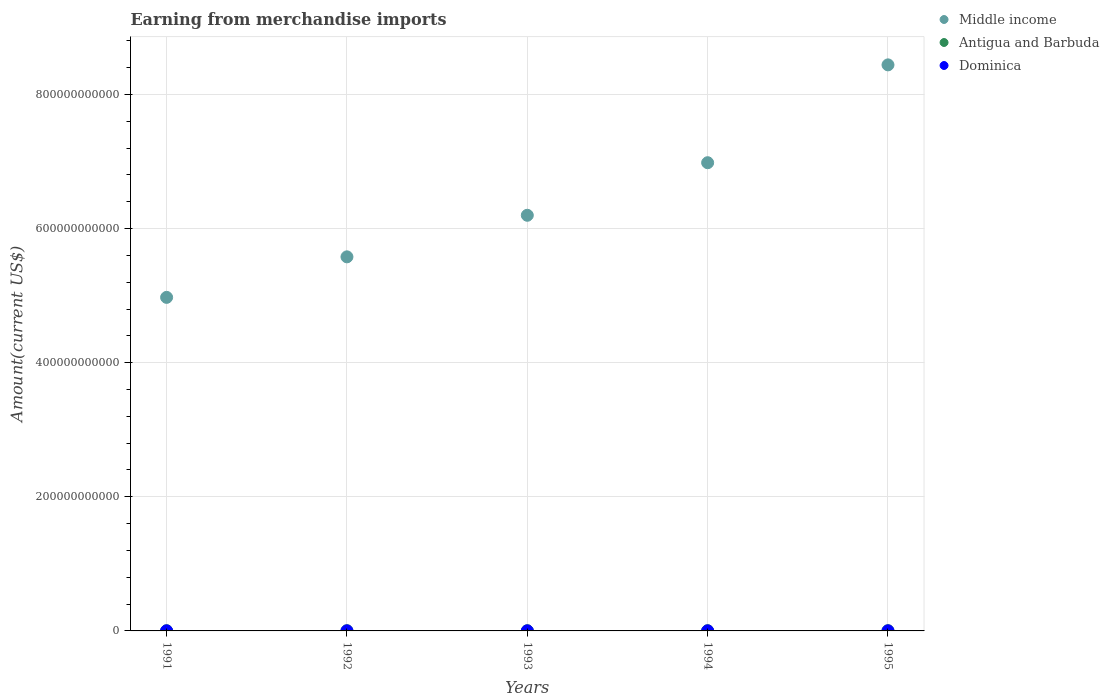How many different coloured dotlines are there?
Your answer should be compact. 3. What is the amount earned from merchandise imports in Middle income in 1995?
Offer a terse response. 8.44e+11. Across all years, what is the maximum amount earned from merchandise imports in Dominica?
Give a very brief answer. 1.17e+08. Across all years, what is the minimum amount earned from merchandise imports in Middle income?
Ensure brevity in your answer.  4.97e+11. What is the total amount earned from merchandise imports in Antigua and Barbuda in the graph?
Your answer should be compact. 1.62e+09. What is the difference between the amount earned from merchandise imports in Middle income in 1991 and that in 1994?
Offer a terse response. -2.01e+11. What is the difference between the amount earned from merchandise imports in Dominica in 1993 and the amount earned from merchandise imports in Middle income in 1991?
Provide a short and direct response. -4.97e+11. What is the average amount earned from merchandise imports in Antigua and Barbuda per year?
Ensure brevity in your answer.  3.24e+08. In the year 1993, what is the difference between the amount earned from merchandise imports in Dominica and amount earned from merchandise imports in Middle income?
Make the answer very short. -6.20e+11. In how many years, is the amount earned from merchandise imports in Antigua and Barbuda greater than 40000000000 US$?
Provide a succinct answer. 0. What is the ratio of the amount earned from merchandise imports in Dominica in 1991 to that in 1994?
Your response must be concise. 1.15. Is the amount earned from merchandise imports in Antigua and Barbuda in 1993 less than that in 1994?
Your response must be concise. Yes. Is the difference between the amount earned from merchandise imports in Dominica in 1991 and 1994 greater than the difference between the amount earned from merchandise imports in Middle income in 1991 and 1994?
Your answer should be compact. Yes. What is the difference between the highest and the second highest amount earned from merchandise imports in Antigua and Barbuda?
Give a very brief answer. 4.00e+06. What is the difference between the highest and the lowest amount earned from merchandise imports in Dominica?
Ensure brevity in your answer.  2.30e+07. In how many years, is the amount earned from merchandise imports in Antigua and Barbuda greater than the average amount earned from merchandise imports in Antigua and Barbuda taken over all years?
Give a very brief answer. 2. Is it the case that in every year, the sum of the amount earned from merchandise imports in Middle income and amount earned from merchandise imports in Dominica  is greater than the amount earned from merchandise imports in Antigua and Barbuda?
Offer a terse response. Yes. Does the amount earned from merchandise imports in Antigua and Barbuda monotonically increase over the years?
Your answer should be compact. Yes. Is the amount earned from merchandise imports in Antigua and Barbuda strictly less than the amount earned from merchandise imports in Dominica over the years?
Keep it short and to the point. No. What is the difference between two consecutive major ticks on the Y-axis?
Offer a very short reply. 2.00e+11. Does the graph contain any zero values?
Your answer should be compact. No. Does the graph contain grids?
Offer a terse response. Yes. How many legend labels are there?
Provide a succinct answer. 3. How are the legend labels stacked?
Provide a succinct answer. Vertical. What is the title of the graph?
Provide a short and direct response. Earning from merchandise imports. What is the label or title of the X-axis?
Provide a succinct answer. Years. What is the label or title of the Y-axis?
Your answer should be very brief. Amount(current US$). What is the Amount(current US$) of Middle income in 1991?
Ensure brevity in your answer.  4.97e+11. What is the Amount(current US$) of Antigua and Barbuda in 1991?
Keep it short and to the point. 2.95e+08. What is the Amount(current US$) of Dominica in 1991?
Give a very brief answer. 1.10e+08. What is the Amount(current US$) of Middle income in 1992?
Offer a very short reply. 5.58e+11. What is the Amount(current US$) of Antigua and Barbuda in 1992?
Offer a very short reply. 3.12e+08. What is the Amount(current US$) in Dominica in 1992?
Provide a short and direct response. 1.05e+08. What is the Amount(current US$) in Middle income in 1993?
Make the answer very short. 6.20e+11. What is the Amount(current US$) in Antigua and Barbuda in 1993?
Provide a short and direct response. 3.23e+08. What is the Amount(current US$) of Dominica in 1993?
Make the answer very short. 9.40e+07. What is the Amount(current US$) in Middle income in 1994?
Provide a short and direct response. 6.98e+11. What is the Amount(current US$) in Antigua and Barbuda in 1994?
Your answer should be very brief. 3.42e+08. What is the Amount(current US$) of Dominica in 1994?
Ensure brevity in your answer.  9.60e+07. What is the Amount(current US$) of Middle income in 1995?
Provide a succinct answer. 8.44e+11. What is the Amount(current US$) in Antigua and Barbuda in 1995?
Offer a very short reply. 3.46e+08. What is the Amount(current US$) of Dominica in 1995?
Offer a terse response. 1.17e+08. Across all years, what is the maximum Amount(current US$) in Middle income?
Provide a succinct answer. 8.44e+11. Across all years, what is the maximum Amount(current US$) of Antigua and Barbuda?
Provide a succinct answer. 3.46e+08. Across all years, what is the maximum Amount(current US$) of Dominica?
Keep it short and to the point. 1.17e+08. Across all years, what is the minimum Amount(current US$) of Middle income?
Provide a short and direct response. 4.97e+11. Across all years, what is the minimum Amount(current US$) in Antigua and Barbuda?
Provide a succinct answer. 2.95e+08. Across all years, what is the minimum Amount(current US$) of Dominica?
Give a very brief answer. 9.40e+07. What is the total Amount(current US$) in Middle income in the graph?
Make the answer very short. 3.22e+12. What is the total Amount(current US$) of Antigua and Barbuda in the graph?
Keep it short and to the point. 1.62e+09. What is the total Amount(current US$) in Dominica in the graph?
Ensure brevity in your answer.  5.22e+08. What is the difference between the Amount(current US$) of Middle income in 1991 and that in 1992?
Your answer should be very brief. -6.04e+1. What is the difference between the Amount(current US$) in Antigua and Barbuda in 1991 and that in 1992?
Your answer should be compact. -1.70e+07. What is the difference between the Amount(current US$) of Middle income in 1991 and that in 1993?
Keep it short and to the point. -1.22e+11. What is the difference between the Amount(current US$) in Antigua and Barbuda in 1991 and that in 1993?
Keep it short and to the point. -2.80e+07. What is the difference between the Amount(current US$) in Dominica in 1991 and that in 1993?
Provide a succinct answer. 1.60e+07. What is the difference between the Amount(current US$) in Middle income in 1991 and that in 1994?
Provide a succinct answer. -2.01e+11. What is the difference between the Amount(current US$) in Antigua and Barbuda in 1991 and that in 1994?
Give a very brief answer. -4.70e+07. What is the difference between the Amount(current US$) in Dominica in 1991 and that in 1994?
Offer a terse response. 1.40e+07. What is the difference between the Amount(current US$) in Middle income in 1991 and that in 1995?
Your answer should be compact. -3.47e+11. What is the difference between the Amount(current US$) in Antigua and Barbuda in 1991 and that in 1995?
Offer a terse response. -5.10e+07. What is the difference between the Amount(current US$) in Dominica in 1991 and that in 1995?
Offer a terse response. -7.00e+06. What is the difference between the Amount(current US$) of Middle income in 1992 and that in 1993?
Ensure brevity in your answer.  -6.20e+1. What is the difference between the Amount(current US$) in Antigua and Barbuda in 1992 and that in 1993?
Offer a very short reply. -1.10e+07. What is the difference between the Amount(current US$) in Dominica in 1992 and that in 1993?
Ensure brevity in your answer.  1.10e+07. What is the difference between the Amount(current US$) in Middle income in 1992 and that in 1994?
Make the answer very short. -1.40e+11. What is the difference between the Amount(current US$) of Antigua and Barbuda in 1992 and that in 1994?
Your response must be concise. -3.00e+07. What is the difference between the Amount(current US$) of Dominica in 1992 and that in 1994?
Make the answer very short. 9.00e+06. What is the difference between the Amount(current US$) in Middle income in 1992 and that in 1995?
Provide a short and direct response. -2.86e+11. What is the difference between the Amount(current US$) in Antigua and Barbuda in 1992 and that in 1995?
Provide a short and direct response. -3.40e+07. What is the difference between the Amount(current US$) in Dominica in 1992 and that in 1995?
Provide a succinct answer. -1.20e+07. What is the difference between the Amount(current US$) of Middle income in 1993 and that in 1994?
Keep it short and to the point. -7.84e+1. What is the difference between the Amount(current US$) of Antigua and Barbuda in 1993 and that in 1994?
Your answer should be very brief. -1.90e+07. What is the difference between the Amount(current US$) of Dominica in 1993 and that in 1994?
Give a very brief answer. -2.00e+06. What is the difference between the Amount(current US$) of Middle income in 1993 and that in 1995?
Provide a short and direct response. -2.24e+11. What is the difference between the Amount(current US$) of Antigua and Barbuda in 1993 and that in 1995?
Give a very brief answer. -2.30e+07. What is the difference between the Amount(current US$) of Dominica in 1993 and that in 1995?
Provide a succinct answer. -2.30e+07. What is the difference between the Amount(current US$) in Middle income in 1994 and that in 1995?
Your answer should be compact. -1.46e+11. What is the difference between the Amount(current US$) in Dominica in 1994 and that in 1995?
Your response must be concise. -2.10e+07. What is the difference between the Amount(current US$) of Middle income in 1991 and the Amount(current US$) of Antigua and Barbuda in 1992?
Give a very brief answer. 4.97e+11. What is the difference between the Amount(current US$) in Middle income in 1991 and the Amount(current US$) in Dominica in 1992?
Offer a terse response. 4.97e+11. What is the difference between the Amount(current US$) in Antigua and Barbuda in 1991 and the Amount(current US$) in Dominica in 1992?
Provide a succinct answer. 1.90e+08. What is the difference between the Amount(current US$) in Middle income in 1991 and the Amount(current US$) in Antigua and Barbuda in 1993?
Your response must be concise. 4.97e+11. What is the difference between the Amount(current US$) in Middle income in 1991 and the Amount(current US$) in Dominica in 1993?
Your answer should be compact. 4.97e+11. What is the difference between the Amount(current US$) of Antigua and Barbuda in 1991 and the Amount(current US$) of Dominica in 1993?
Provide a succinct answer. 2.01e+08. What is the difference between the Amount(current US$) in Middle income in 1991 and the Amount(current US$) in Antigua and Barbuda in 1994?
Give a very brief answer. 4.97e+11. What is the difference between the Amount(current US$) of Middle income in 1991 and the Amount(current US$) of Dominica in 1994?
Provide a succinct answer. 4.97e+11. What is the difference between the Amount(current US$) of Antigua and Barbuda in 1991 and the Amount(current US$) of Dominica in 1994?
Your answer should be very brief. 1.99e+08. What is the difference between the Amount(current US$) of Middle income in 1991 and the Amount(current US$) of Antigua and Barbuda in 1995?
Offer a very short reply. 4.97e+11. What is the difference between the Amount(current US$) in Middle income in 1991 and the Amount(current US$) in Dominica in 1995?
Your response must be concise. 4.97e+11. What is the difference between the Amount(current US$) in Antigua and Barbuda in 1991 and the Amount(current US$) in Dominica in 1995?
Your response must be concise. 1.78e+08. What is the difference between the Amount(current US$) of Middle income in 1992 and the Amount(current US$) of Antigua and Barbuda in 1993?
Your response must be concise. 5.57e+11. What is the difference between the Amount(current US$) in Middle income in 1992 and the Amount(current US$) in Dominica in 1993?
Ensure brevity in your answer.  5.58e+11. What is the difference between the Amount(current US$) in Antigua and Barbuda in 1992 and the Amount(current US$) in Dominica in 1993?
Give a very brief answer. 2.18e+08. What is the difference between the Amount(current US$) of Middle income in 1992 and the Amount(current US$) of Antigua and Barbuda in 1994?
Your response must be concise. 5.57e+11. What is the difference between the Amount(current US$) of Middle income in 1992 and the Amount(current US$) of Dominica in 1994?
Your answer should be very brief. 5.58e+11. What is the difference between the Amount(current US$) in Antigua and Barbuda in 1992 and the Amount(current US$) in Dominica in 1994?
Keep it short and to the point. 2.16e+08. What is the difference between the Amount(current US$) in Middle income in 1992 and the Amount(current US$) in Antigua and Barbuda in 1995?
Provide a short and direct response. 5.57e+11. What is the difference between the Amount(current US$) of Middle income in 1992 and the Amount(current US$) of Dominica in 1995?
Offer a very short reply. 5.58e+11. What is the difference between the Amount(current US$) in Antigua and Barbuda in 1992 and the Amount(current US$) in Dominica in 1995?
Ensure brevity in your answer.  1.95e+08. What is the difference between the Amount(current US$) of Middle income in 1993 and the Amount(current US$) of Antigua and Barbuda in 1994?
Provide a succinct answer. 6.19e+11. What is the difference between the Amount(current US$) in Middle income in 1993 and the Amount(current US$) in Dominica in 1994?
Make the answer very short. 6.20e+11. What is the difference between the Amount(current US$) of Antigua and Barbuda in 1993 and the Amount(current US$) of Dominica in 1994?
Provide a succinct answer. 2.27e+08. What is the difference between the Amount(current US$) in Middle income in 1993 and the Amount(current US$) in Antigua and Barbuda in 1995?
Provide a succinct answer. 6.19e+11. What is the difference between the Amount(current US$) of Middle income in 1993 and the Amount(current US$) of Dominica in 1995?
Your response must be concise. 6.20e+11. What is the difference between the Amount(current US$) in Antigua and Barbuda in 1993 and the Amount(current US$) in Dominica in 1995?
Ensure brevity in your answer.  2.06e+08. What is the difference between the Amount(current US$) in Middle income in 1994 and the Amount(current US$) in Antigua and Barbuda in 1995?
Offer a terse response. 6.98e+11. What is the difference between the Amount(current US$) in Middle income in 1994 and the Amount(current US$) in Dominica in 1995?
Make the answer very short. 6.98e+11. What is the difference between the Amount(current US$) of Antigua and Barbuda in 1994 and the Amount(current US$) of Dominica in 1995?
Offer a terse response. 2.25e+08. What is the average Amount(current US$) in Middle income per year?
Provide a short and direct response. 6.43e+11. What is the average Amount(current US$) in Antigua and Barbuda per year?
Your answer should be very brief. 3.24e+08. What is the average Amount(current US$) in Dominica per year?
Your response must be concise. 1.04e+08. In the year 1991, what is the difference between the Amount(current US$) of Middle income and Amount(current US$) of Antigua and Barbuda?
Keep it short and to the point. 4.97e+11. In the year 1991, what is the difference between the Amount(current US$) of Middle income and Amount(current US$) of Dominica?
Offer a very short reply. 4.97e+11. In the year 1991, what is the difference between the Amount(current US$) in Antigua and Barbuda and Amount(current US$) in Dominica?
Offer a very short reply. 1.85e+08. In the year 1992, what is the difference between the Amount(current US$) of Middle income and Amount(current US$) of Antigua and Barbuda?
Ensure brevity in your answer.  5.57e+11. In the year 1992, what is the difference between the Amount(current US$) of Middle income and Amount(current US$) of Dominica?
Your answer should be compact. 5.58e+11. In the year 1992, what is the difference between the Amount(current US$) of Antigua and Barbuda and Amount(current US$) of Dominica?
Give a very brief answer. 2.07e+08. In the year 1993, what is the difference between the Amount(current US$) in Middle income and Amount(current US$) in Antigua and Barbuda?
Provide a short and direct response. 6.19e+11. In the year 1993, what is the difference between the Amount(current US$) in Middle income and Amount(current US$) in Dominica?
Offer a very short reply. 6.20e+11. In the year 1993, what is the difference between the Amount(current US$) of Antigua and Barbuda and Amount(current US$) of Dominica?
Ensure brevity in your answer.  2.29e+08. In the year 1994, what is the difference between the Amount(current US$) of Middle income and Amount(current US$) of Antigua and Barbuda?
Give a very brief answer. 6.98e+11. In the year 1994, what is the difference between the Amount(current US$) in Middle income and Amount(current US$) in Dominica?
Your answer should be very brief. 6.98e+11. In the year 1994, what is the difference between the Amount(current US$) in Antigua and Barbuda and Amount(current US$) in Dominica?
Make the answer very short. 2.46e+08. In the year 1995, what is the difference between the Amount(current US$) of Middle income and Amount(current US$) of Antigua and Barbuda?
Offer a terse response. 8.44e+11. In the year 1995, what is the difference between the Amount(current US$) of Middle income and Amount(current US$) of Dominica?
Offer a very short reply. 8.44e+11. In the year 1995, what is the difference between the Amount(current US$) of Antigua and Barbuda and Amount(current US$) of Dominica?
Provide a short and direct response. 2.29e+08. What is the ratio of the Amount(current US$) of Middle income in 1991 to that in 1992?
Offer a terse response. 0.89. What is the ratio of the Amount(current US$) of Antigua and Barbuda in 1991 to that in 1992?
Offer a very short reply. 0.95. What is the ratio of the Amount(current US$) of Dominica in 1991 to that in 1992?
Your answer should be compact. 1.05. What is the ratio of the Amount(current US$) in Middle income in 1991 to that in 1993?
Offer a terse response. 0.8. What is the ratio of the Amount(current US$) of Antigua and Barbuda in 1991 to that in 1993?
Make the answer very short. 0.91. What is the ratio of the Amount(current US$) of Dominica in 1991 to that in 1993?
Offer a very short reply. 1.17. What is the ratio of the Amount(current US$) in Middle income in 1991 to that in 1994?
Provide a short and direct response. 0.71. What is the ratio of the Amount(current US$) of Antigua and Barbuda in 1991 to that in 1994?
Provide a short and direct response. 0.86. What is the ratio of the Amount(current US$) in Dominica in 1991 to that in 1994?
Your answer should be very brief. 1.15. What is the ratio of the Amount(current US$) of Middle income in 1991 to that in 1995?
Keep it short and to the point. 0.59. What is the ratio of the Amount(current US$) in Antigua and Barbuda in 1991 to that in 1995?
Keep it short and to the point. 0.85. What is the ratio of the Amount(current US$) in Dominica in 1991 to that in 1995?
Your answer should be very brief. 0.94. What is the ratio of the Amount(current US$) of Middle income in 1992 to that in 1993?
Your response must be concise. 0.9. What is the ratio of the Amount(current US$) of Antigua and Barbuda in 1992 to that in 1993?
Provide a short and direct response. 0.97. What is the ratio of the Amount(current US$) of Dominica in 1992 to that in 1993?
Your answer should be very brief. 1.12. What is the ratio of the Amount(current US$) in Middle income in 1992 to that in 1994?
Provide a succinct answer. 0.8. What is the ratio of the Amount(current US$) of Antigua and Barbuda in 1992 to that in 1994?
Offer a very short reply. 0.91. What is the ratio of the Amount(current US$) in Dominica in 1992 to that in 1994?
Provide a short and direct response. 1.09. What is the ratio of the Amount(current US$) in Middle income in 1992 to that in 1995?
Your answer should be compact. 0.66. What is the ratio of the Amount(current US$) of Antigua and Barbuda in 1992 to that in 1995?
Provide a succinct answer. 0.9. What is the ratio of the Amount(current US$) of Dominica in 1992 to that in 1995?
Offer a terse response. 0.9. What is the ratio of the Amount(current US$) in Middle income in 1993 to that in 1994?
Your response must be concise. 0.89. What is the ratio of the Amount(current US$) in Antigua and Barbuda in 1993 to that in 1994?
Offer a terse response. 0.94. What is the ratio of the Amount(current US$) of Dominica in 1993 to that in 1994?
Offer a terse response. 0.98. What is the ratio of the Amount(current US$) in Middle income in 1993 to that in 1995?
Ensure brevity in your answer.  0.73. What is the ratio of the Amount(current US$) of Antigua and Barbuda in 1993 to that in 1995?
Ensure brevity in your answer.  0.93. What is the ratio of the Amount(current US$) of Dominica in 1993 to that in 1995?
Offer a very short reply. 0.8. What is the ratio of the Amount(current US$) of Middle income in 1994 to that in 1995?
Give a very brief answer. 0.83. What is the ratio of the Amount(current US$) in Antigua and Barbuda in 1994 to that in 1995?
Keep it short and to the point. 0.99. What is the ratio of the Amount(current US$) of Dominica in 1994 to that in 1995?
Offer a terse response. 0.82. What is the difference between the highest and the second highest Amount(current US$) in Middle income?
Give a very brief answer. 1.46e+11. What is the difference between the highest and the second highest Amount(current US$) in Dominica?
Offer a very short reply. 7.00e+06. What is the difference between the highest and the lowest Amount(current US$) in Middle income?
Give a very brief answer. 3.47e+11. What is the difference between the highest and the lowest Amount(current US$) of Antigua and Barbuda?
Offer a very short reply. 5.10e+07. What is the difference between the highest and the lowest Amount(current US$) in Dominica?
Your answer should be compact. 2.30e+07. 